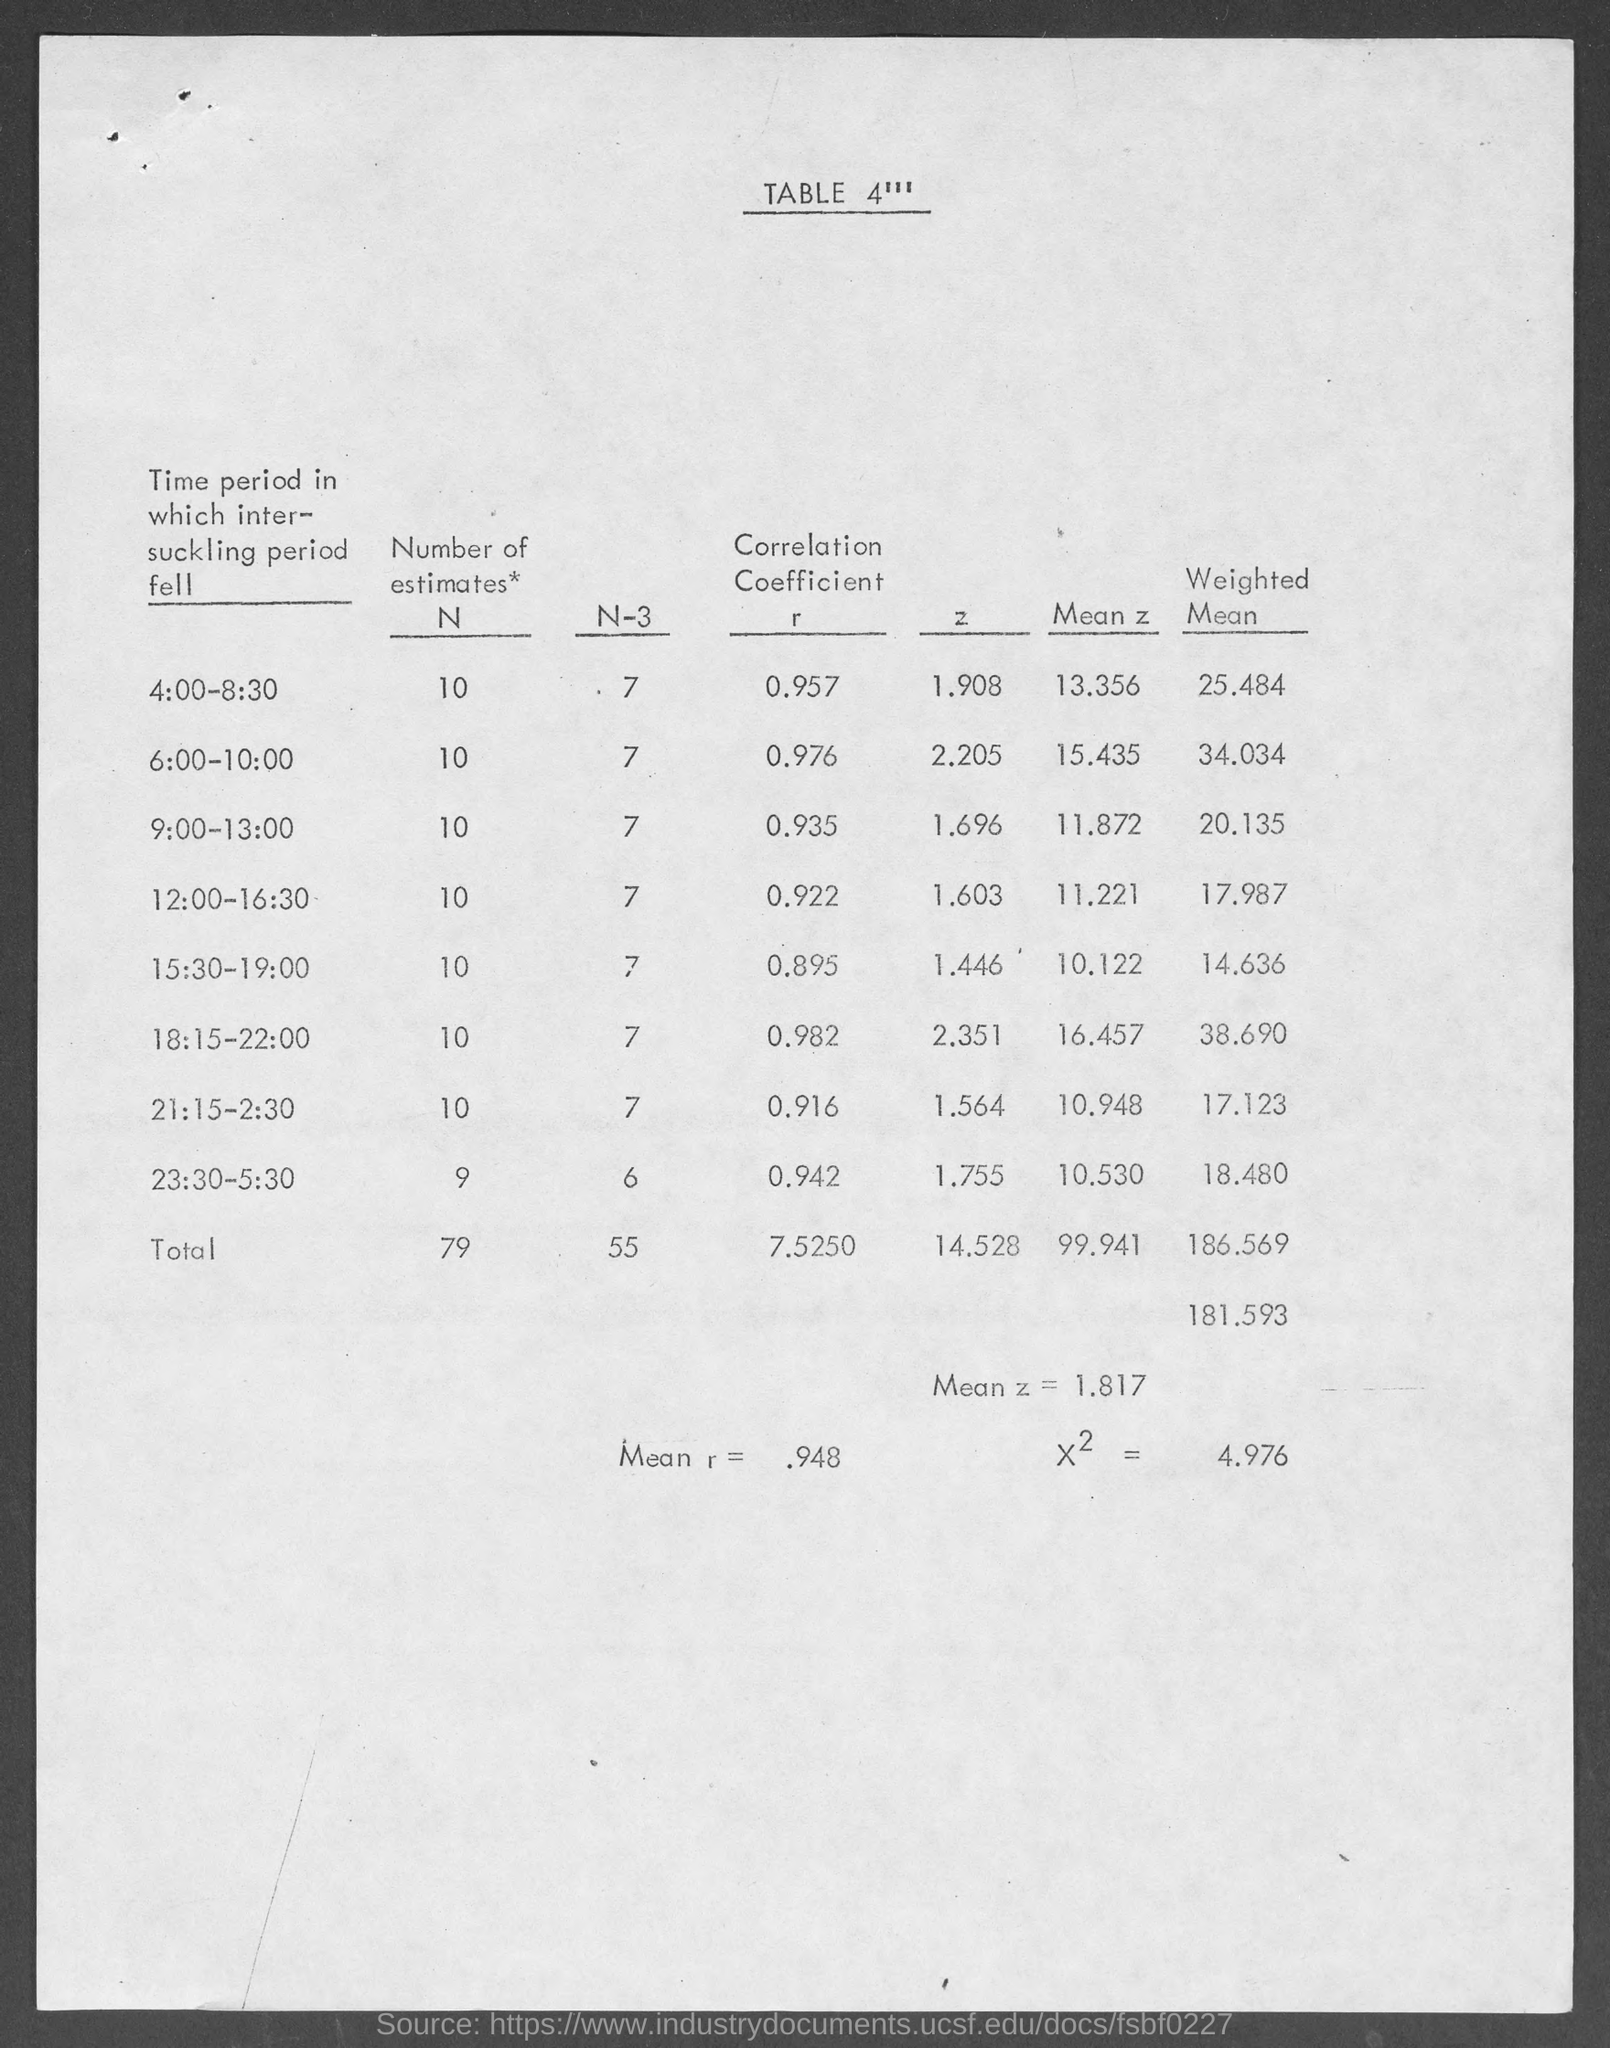What is the table number?
Offer a terse response. 4'''. What is the last column heading of the table?
Offer a terse response. Weighted Mean. What is the Total Mean z ?
Provide a short and direct response. 1.817. What is the Total Mean r ?
Give a very brief answer. .948. 